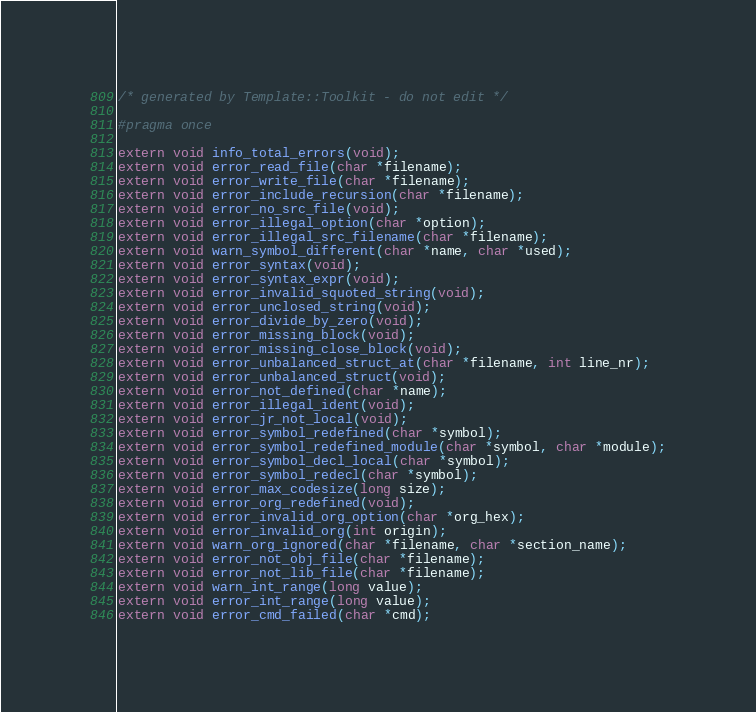Convert code to text. <code><loc_0><loc_0><loc_500><loc_500><_C_>/* generated by Template::Toolkit - do not edit */

#pragma once

extern void info_total_errors(void);
extern void error_read_file(char *filename);
extern void error_write_file(char *filename);
extern void error_include_recursion(char *filename);
extern void error_no_src_file(void);
extern void error_illegal_option(char *option);
extern void error_illegal_src_filename(char *filename);
extern void warn_symbol_different(char *name, char *used);
extern void error_syntax(void);
extern void error_syntax_expr(void);
extern void error_invalid_squoted_string(void);
extern void error_unclosed_string(void);
extern void error_divide_by_zero(void);
extern void error_missing_block(void);
extern void error_missing_close_block(void);
extern void error_unbalanced_struct_at(char *filename, int line_nr);
extern void error_unbalanced_struct(void);
extern void error_not_defined(char *name);
extern void error_illegal_ident(void);
extern void error_jr_not_local(void);
extern void error_symbol_redefined(char *symbol);
extern void error_symbol_redefined_module(char *symbol, char *module);
extern void error_symbol_decl_local(char *symbol);
extern void error_symbol_redecl(char *symbol);
extern void error_max_codesize(long size);
extern void error_org_redefined(void);
extern void error_invalid_org_option(char *org_hex);
extern void error_invalid_org(int origin);
extern void warn_org_ignored(char *filename, char *section_name);
extern void error_not_obj_file(char *filename);
extern void error_not_lib_file(char *filename);
extern void warn_int_range(long value);
extern void error_int_range(long value);
extern void error_cmd_failed(char *cmd);
</code> 